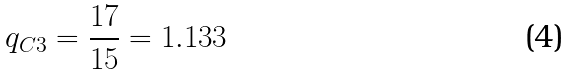Convert formula to latex. <formula><loc_0><loc_0><loc_500><loc_500>q _ { C 3 } = \frac { 1 7 } { 1 5 } = 1 . 1 3 3</formula> 